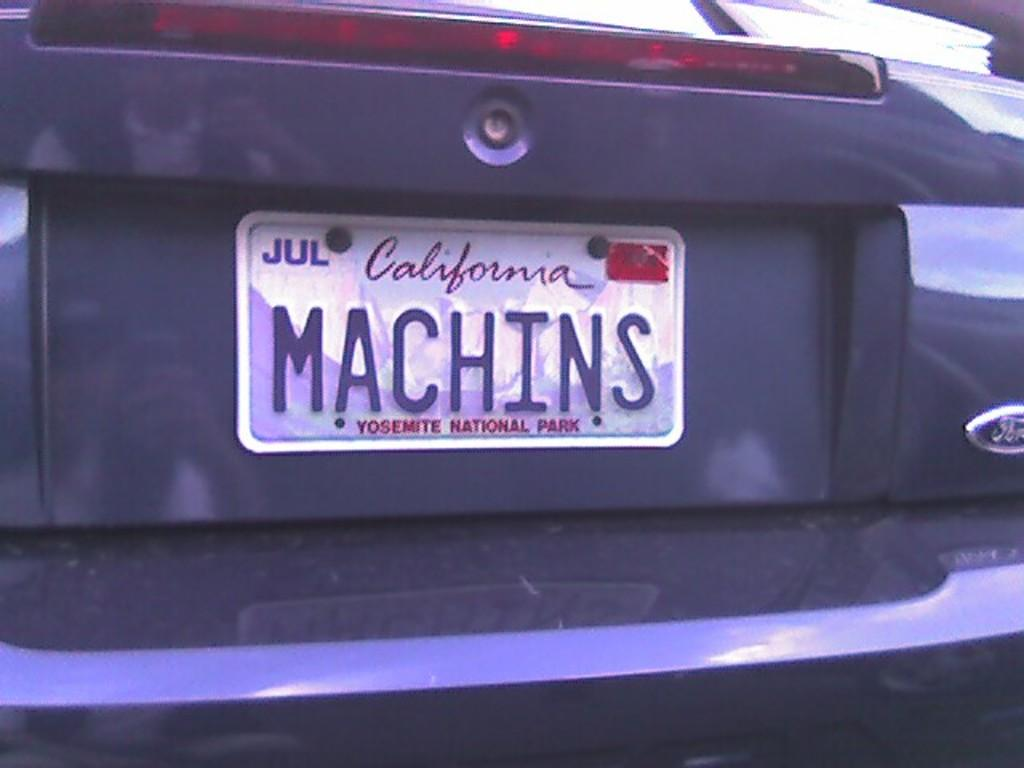<image>
Provide a brief description of the given image. The back of a ford branded vehicle with a California state license plate. 